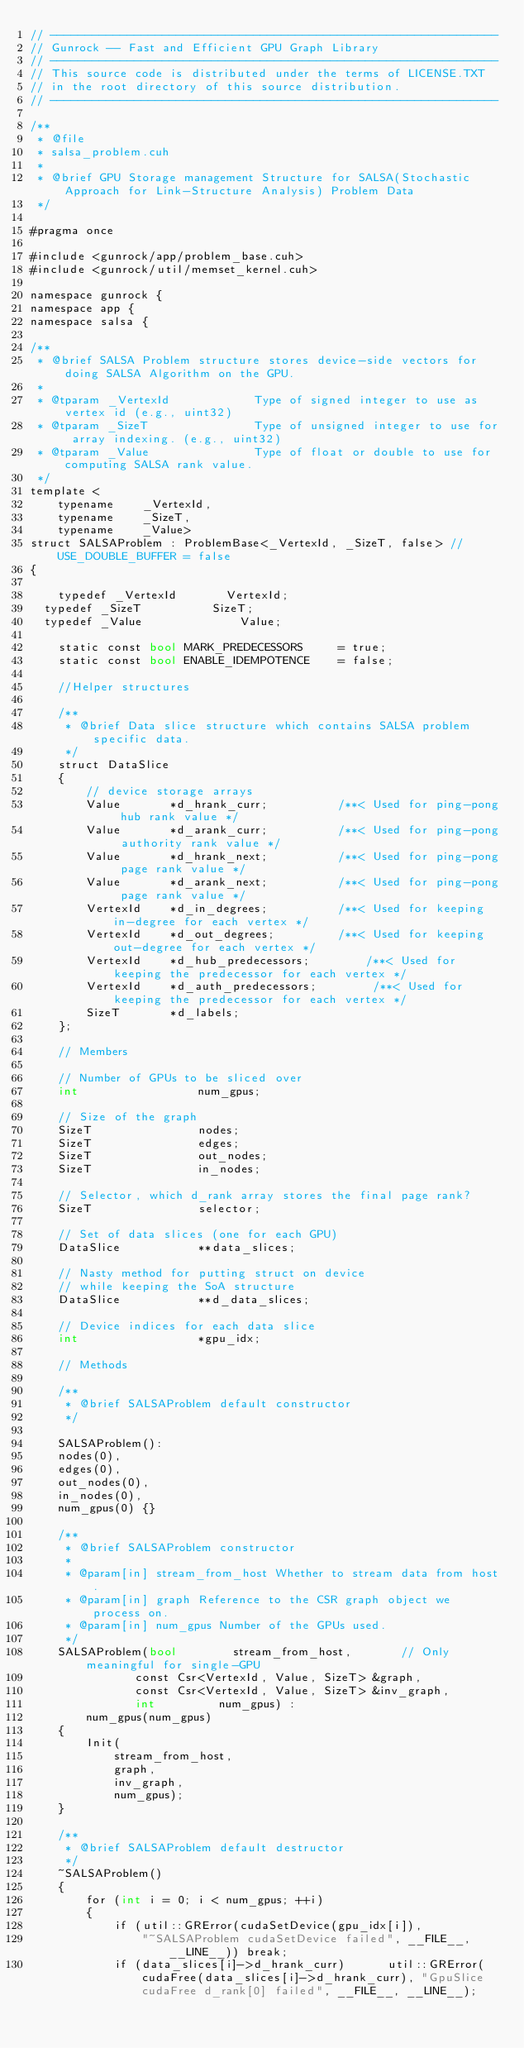Convert code to text. <code><loc_0><loc_0><loc_500><loc_500><_Cuda_>// ----------------------------------------------------------------
// Gunrock -- Fast and Efficient GPU Graph Library
// ----------------------------------------------------------------
// This source code is distributed under the terms of LICENSE.TXT
// in the root directory of this source distribution.
// ----------------------------------------------------------------

/**
 * @file
 * salsa_problem.cuh
 *
 * @brief GPU Storage management Structure for SALSA(Stochastic Approach for Link-Structure Analysis) Problem Data
 */

#pragma once

#include <gunrock/app/problem_base.cuh>
#include <gunrock/util/memset_kernel.cuh>

namespace gunrock {
namespace app {
namespace salsa {

/**
 * @brief SALSA Problem structure stores device-side vectors for doing SALSA Algorithm on the GPU.
 *
 * @tparam _VertexId            Type of signed integer to use as vertex id (e.g., uint32)
 * @tparam _SizeT               Type of unsigned integer to use for array indexing. (e.g., uint32)
 * @tparam _Value               Type of float or double to use for computing SALSA rank value.
 */
template <
    typename    _VertexId,                       
    typename    _SizeT,                          
    typename    _Value>
struct SALSAProblem : ProblemBase<_VertexId, _SizeT, false> // USE_DOUBLE_BUFFER = false
{

    typedef _VertexId 			VertexId;
	typedef _SizeT			    SizeT;
	typedef _Value              Value;

    static const bool MARK_PREDECESSORS     = true;
    static const bool ENABLE_IDEMPOTENCE    = false;

    //Helper structures

    /**
     * @brief Data slice structure which contains SALSA problem specific data.
     */
    struct DataSlice
    {
        // device storage arrays
        Value       *d_hrank_curr;          /**< Used for ping-pong hub rank value */
        Value       *d_arank_curr;          /**< Used for ping-pong authority rank value */
        Value       *d_hrank_next;          /**< Used for ping-pong page rank value */       
        Value       *d_arank_next;          /**< Used for ping-pong page rank value */
        VertexId    *d_in_degrees;          /**< Used for keeping in-degree for each vertex */
        VertexId    *d_out_degrees;         /**< Used for keeping out-degree for each vertex */
        VertexId    *d_hub_predecessors;        /**< Used for keeping the predecessor for each vertex */
        VertexId    *d_auth_predecessors;        /**< Used for keeping the predecessor for each vertex */
        SizeT       *d_labels;
    };

    // Members
    
    // Number of GPUs to be sliced over
    int                 num_gpus;

    // Size of the graph
    SizeT               nodes;
    SizeT               edges;
    SizeT               out_nodes;
    SizeT               in_nodes;

    // Selector, which d_rank array stores the final page rank?
    SizeT               selector;

    // Set of data slices (one for each GPU)
    DataSlice           **data_slices;
   
    // Nasty method for putting struct on device
    // while keeping the SoA structure
    DataSlice           **d_data_slices;

    // Device indices for each data slice
    int                 *gpu_idx;

    // Methods

    /**
     * @brief SALSAProblem default constructor
     */

    SALSAProblem():
    nodes(0),
    edges(0),
    out_nodes(0),
    in_nodes(0),
    num_gpus(0) {}

    /**
     * @brief SALSAProblem constructor
     *
     * @param[in] stream_from_host Whether to stream data from host.
     * @param[in] graph Reference to the CSR graph object we process on.
     * @param[in] num_gpus Number of the GPUs used.
     */
    SALSAProblem(bool        stream_from_host,       // Only meaningful for single-GPU
               const Csr<VertexId, Value, SizeT> &graph,
               const Csr<VertexId, Value, SizeT> &inv_graph,
               int         num_gpus) :
        num_gpus(num_gpus)
    {
        Init(
            stream_from_host,
            graph,
            inv_graph,
            num_gpus);
    }

    /**
     * @brief SALSAProblem default destructor
     */
    ~SALSAProblem()
    {
        for (int i = 0; i < num_gpus; ++i)
        {
            if (util::GRError(cudaSetDevice(gpu_idx[i]),
                "~SALSAProblem cudaSetDevice failed", __FILE__, __LINE__)) break;
            if (data_slices[i]->d_hrank_curr)      util::GRError(cudaFree(data_slices[i]->d_hrank_curr), "GpuSlice cudaFree d_rank[0] failed", __FILE__, __LINE__);</code> 